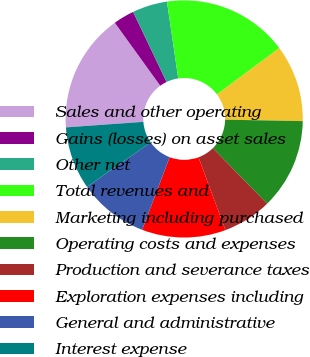Convert chart to OTSL. <chart><loc_0><loc_0><loc_500><loc_500><pie_chart><fcel>Sales and other operating<fcel>Gains (losses) on asset sales<fcel>Other net<fcel>Total revenues and<fcel>Marketing including purchased<fcel>Operating costs and expenses<fcel>Production and severance taxes<fcel>Exploration expenses including<fcel>General and administrative<fcel>Interest expense<nl><fcel>16.19%<fcel>2.86%<fcel>4.76%<fcel>17.14%<fcel>10.48%<fcel>12.38%<fcel>6.67%<fcel>11.43%<fcel>9.52%<fcel>8.57%<nl></chart> 